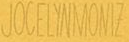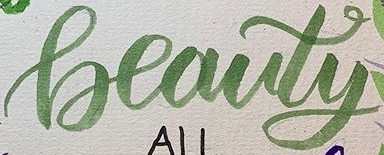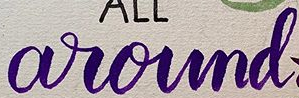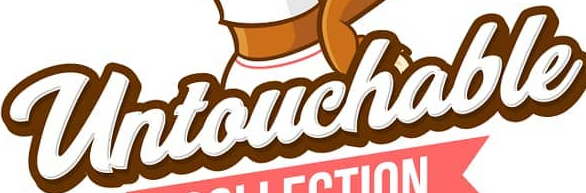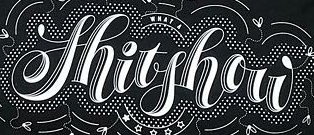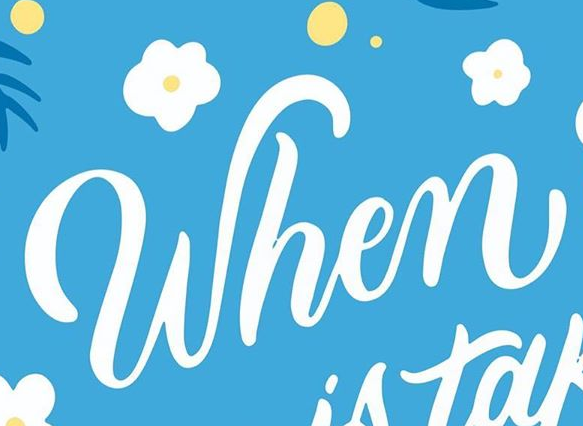What words are shown in these images in order, separated by a semicolon? JOCELYNMONIZ; Beauty; around; Untouchable; Shitshow; When 